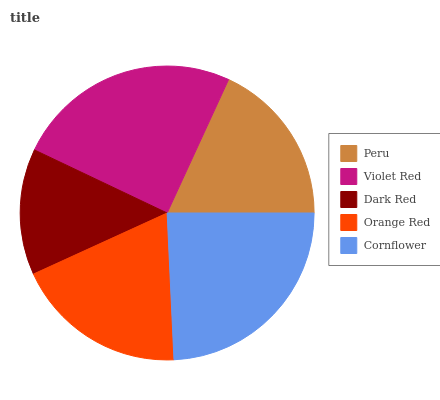Is Dark Red the minimum?
Answer yes or no. Yes. Is Violet Red the maximum?
Answer yes or no. Yes. Is Violet Red the minimum?
Answer yes or no. No. Is Dark Red the maximum?
Answer yes or no. No. Is Violet Red greater than Dark Red?
Answer yes or no. Yes. Is Dark Red less than Violet Red?
Answer yes or no. Yes. Is Dark Red greater than Violet Red?
Answer yes or no. No. Is Violet Red less than Dark Red?
Answer yes or no. No. Is Orange Red the high median?
Answer yes or no. Yes. Is Orange Red the low median?
Answer yes or no. Yes. Is Violet Red the high median?
Answer yes or no. No. Is Violet Red the low median?
Answer yes or no. No. 